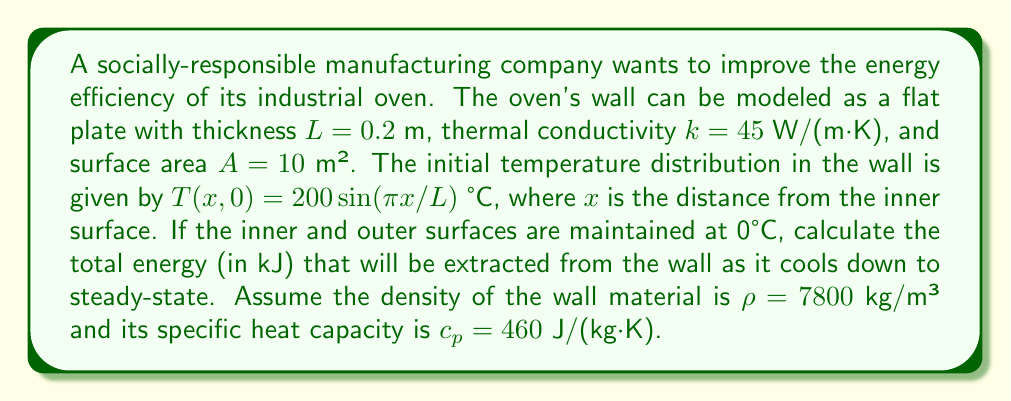Show me your answer to this math problem. To solve this problem, we'll use the heat equation and Fourier series. Let's break it down step-by-step:

1) The heat equation for this scenario is:

   $$\frac{\partial T}{\partial t} = \alpha \frac{\partial^2 T}{\partial x^2}$$

   where $\alpha = k/(\rho c_p)$ is the thermal diffusivity.

2) The steady-state solution with both surfaces at 0°C is $T(x,\infty) = 0$.

3) The initial condition can be written as a Fourier series:

   $$T(x,0) = 200\sin(\pi x/L) = \sum_{n=1}^{\infty} b_n \sin(n\pi x/L)$$

   where $b_1 = 200$ and $b_n = 0$ for $n > 1$.

4) The general solution to the heat equation for these boundary conditions is:

   $$T(x,t) = \sum_{n=1}^{\infty} b_n e^{-\alpha n^2\pi^2t/L^2} \sin(n\pi x/L)$$

5) The energy extracted is the difference between the initial and final energy content:

   $$E = \rho c_p A L \left(\frac{1}{L}\int_0^L T(x,0) dx - \frac{1}{L}\int_0^L T(x,\infty) dx\right)$$

6) Substituting the initial condition:

   $$E = \rho c_p A L \left(\frac{1}{L}\int_0^L 200\sin(\pi x/L) dx - 0\right)$$

7) Solving the integral:

   $$E = \rho c_p A L \left(\frac{200L}{\pi} - 0\right) = \frac{200\rho c_p A L}{\pi}$$

8) Substituting the given values:

   $$E = \frac{200 \cdot 7800 \cdot 460 \cdot 10 \cdot 0.2}{\pi} = 4.55 \times 10^8 \text{ J} = 455000 \text{ kJ}$$
Answer: 455000 kJ 